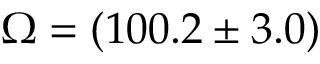Convert formula to latex. <formula><loc_0><loc_0><loc_500><loc_500>\Omega = ( 1 0 0 . 2 \pm 3 . 0 )</formula> 